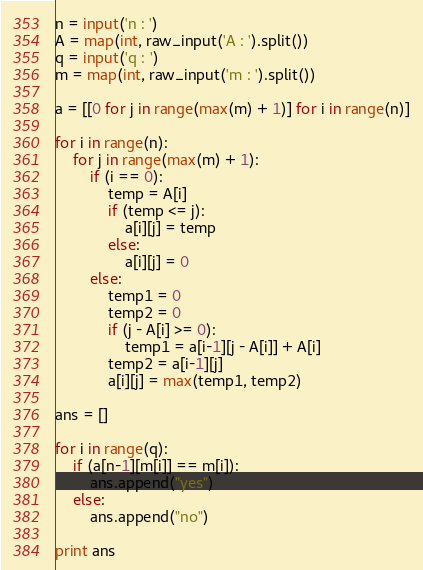<code> <loc_0><loc_0><loc_500><loc_500><_Python_>n = input('n : ')
A = map(int, raw_input('A : ').split())
q = input('q : ')
m = map(int, raw_input('m : ').split())

a = [[0 for j in range(max(m) + 1)] for i in range(n)]

for i in range(n):
    for j in range(max(m) + 1):
        if (i == 0):
            temp = A[i]
            if (temp <= j):
                a[i][j] = temp
            else:
                a[i][j] = 0
        else:
            temp1 = 0
            temp2 = 0
            if (j - A[i] >= 0):
                temp1 = a[i-1][j - A[i]] + A[i]
            temp2 = a[i-1][j]
            a[i][j] = max(temp1, temp2)

ans = []

for i in range(q):
    if (a[n-1][m[i]] == m[i]):
        ans.append("yes")
    else:
        ans.append("no")

print ans</code> 